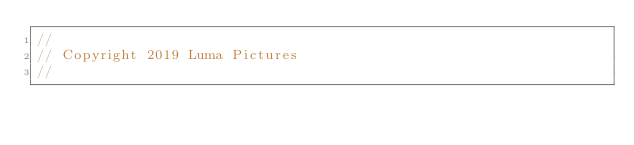<code> <loc_0><loc_0><loc_500><loc_500><_C++_>//
// Copyright 2019 Luma Pictures
//</code> 